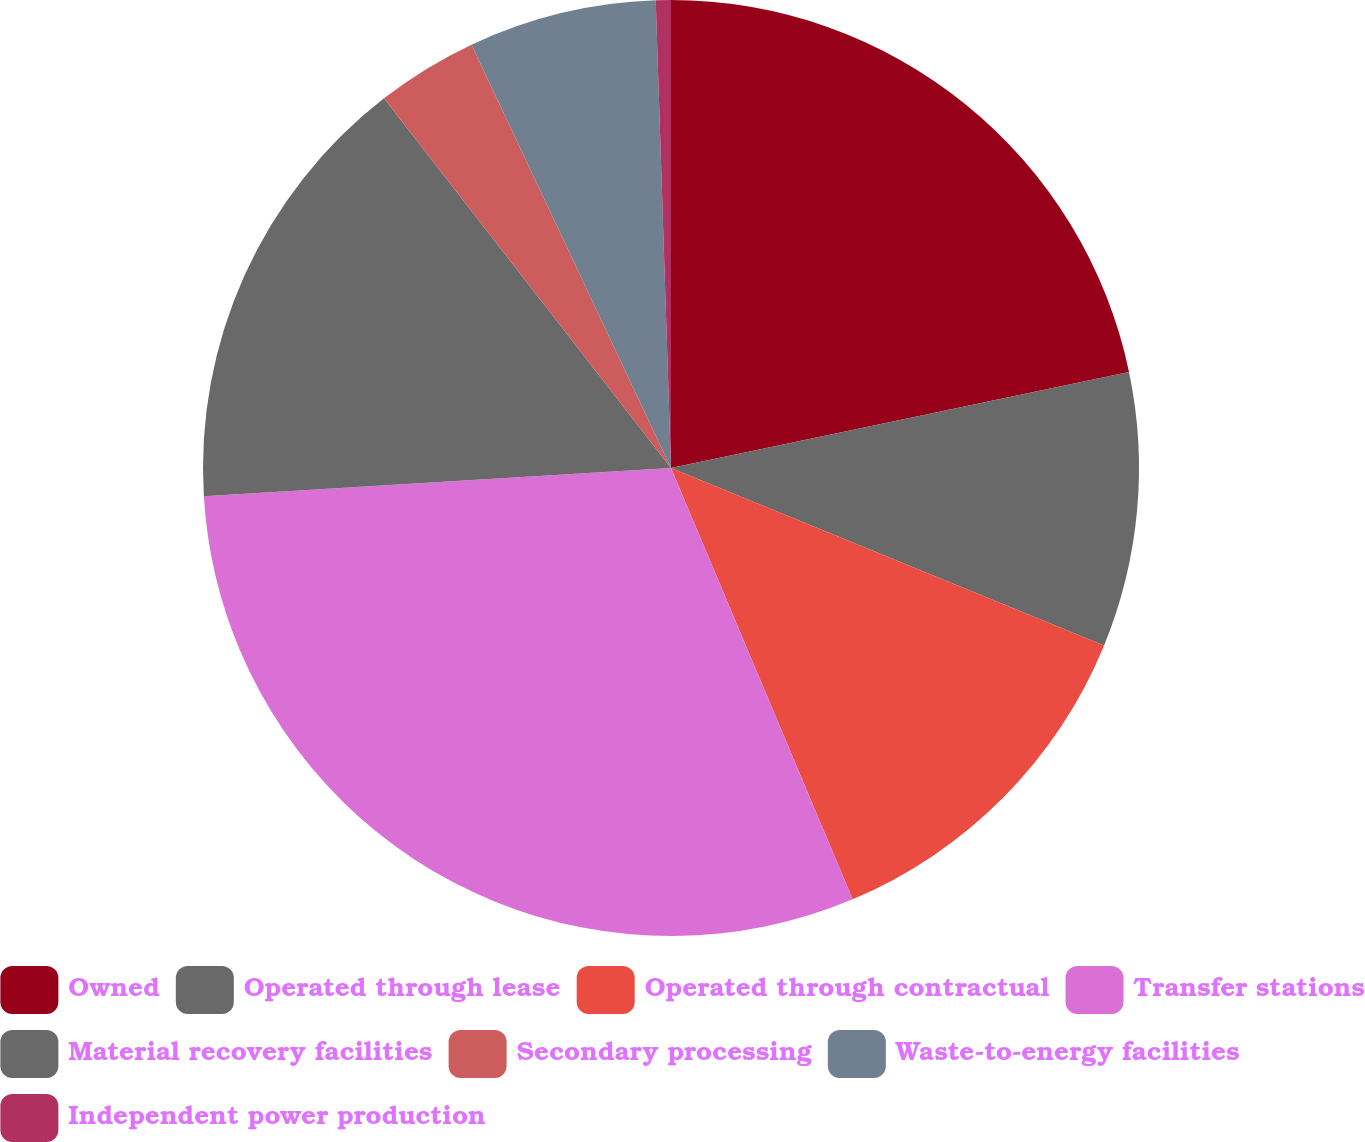<chart> <loc_0><loc_0><loc_500><loc_500><pie_chart><fcel>Owned<fcel>Operated through lease<fcel>Operated through contractual<fcel>Transfer stations<fcel>Material recovery facilities<fcel>Secondary processing<fcel>Waste-to-energy facilities<fcel>Independent power production<nl><fcel>21.71%<fcel>9.48%<fcel>12.47%<fcel>30.39%<fcel>15.45%<fcel>3.5%<fcel>6.49%<fcel>0.52%<nl></chart> 